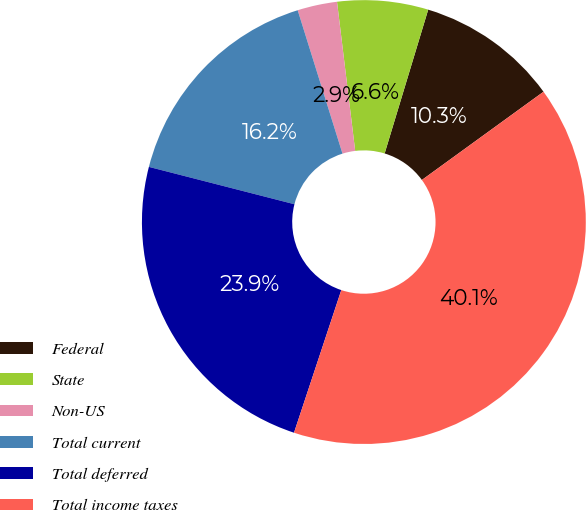<chart> <loc_0><loc_0><loc_500><loc_500><pie_chart><fcel>Federal<fcel>State<fcel>Non-US<fcel>Total current<fcel>Total deferred<fcel>Total income taxes<nl><fcel>10.33%<fcel>6.61%<fcel>2.89%<fcel>16.18%<fcel>23.9%<fcel>40.08%<nl></chart> 